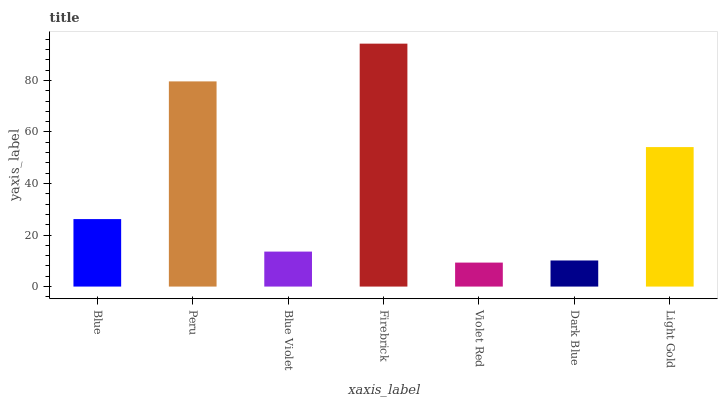Is Violet Red the minimum?
Answer yes or no. Yes. Is Firebrick the maximum?
Answer yes or no. Yes. Is Peru the minimum?
Answer yes or no. No. Is Peru the maximum?
Answer yes or no. No. Is Peru greater than Blue?
Answer yes or no. Yes. Is Blue less than Peru?
Answer yes or no. Yes. Is Blue greater than Peru?
Answer yes or no. No. Is Peru less than Blue?
Answer yes or no. No. Is Blue the high median?
Answer yes or no. Yes. Is Blue the low median?
Answer yes or no. Yes. Is Blue Violet the high median?
Answer yes or no. No. Is Light Gold the low median?
Answer yes or no. No. 